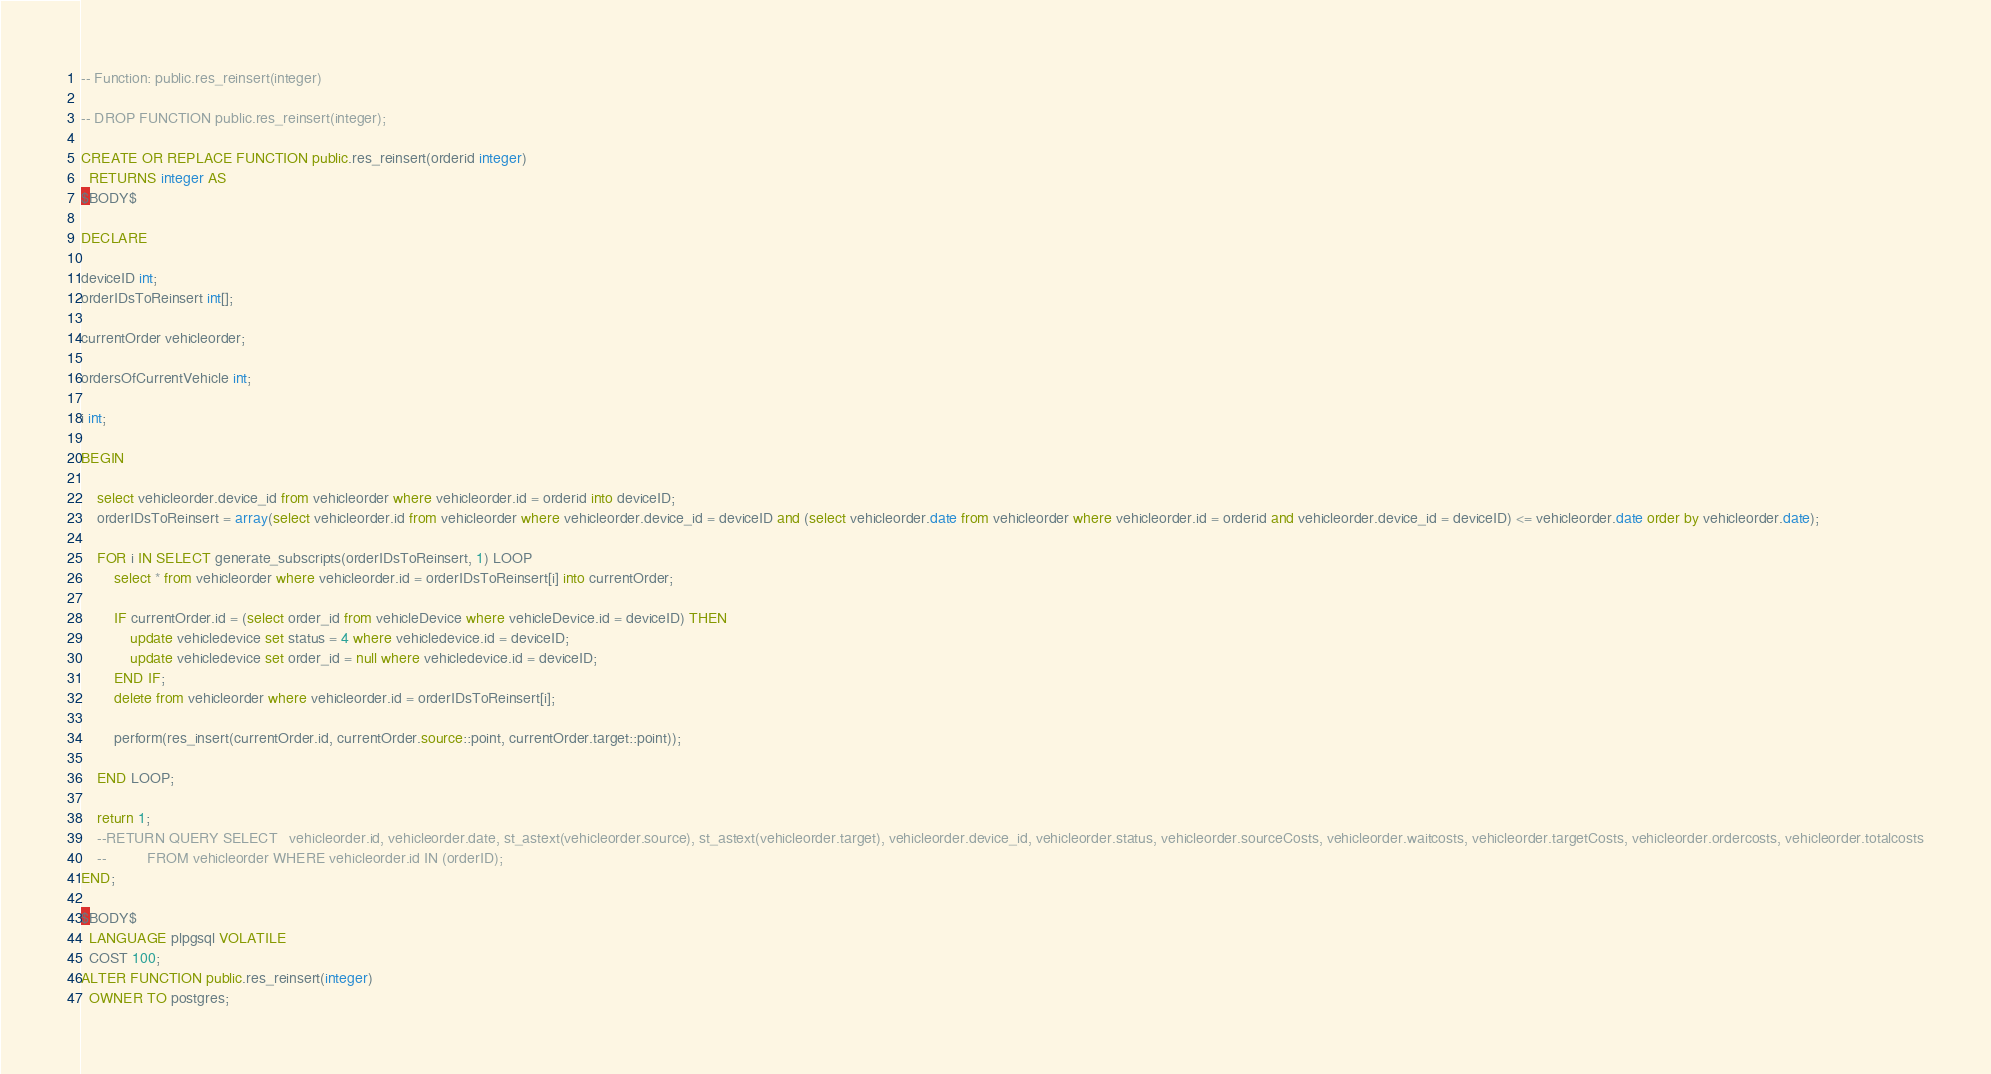Convert code to text. <code><loc_0><loc_0><loc_500><loc_500><_SQL_>-- Function: public.res_reinsert(integer)

-- DROP FUNCTION public.res_reinsert(integer);

CREATE OR REPLACE FUNCTION public.res_reinsert(orderid integer)
  RETURNS integer AS
$BODY$

DECLARE

deviceID int;
orderIDsToReinsert int[];

currentOrder vehicleorder;

ordersOfCurrentVehicle int;

i int;

BEGIN

	select vehicleorder.device_id from vehicleorder where vehicleorder.id = orderid into deviceID;
	orderIDsToReinsert = array(select vehicleorder.id from vehicleorder where vehicleorder.device_id = deviceID and (select vehicleorder.date from vehicleorder where vehicleorder.id = orderid and vehicleorder.device_id = deviceID) <= vehicleorder.date order by vehicleorder.date);

	FOR i IN SELECT generate_subscripts(orderIDsToReinsert, 1) LOOP
		select * from vehicleorder where vehicleorder.id = orderIDsToReinsert[i] into currentOrder;

		IF currentOrder.id = (select order_id from vehicleDevice where vehicleDevice.id = deviceID) THEN
			update vehicledevice set status = 4 where vehicledevice.id = deviceID;
			update vehicledevice set order_id = null where vehicledevice.id = deviceID;
		END IF;
		delete from vehicleorder where vehicleorder.id = orderIDsToReinsert[i];

		perform(res_insert(currentOrder.id, currentOrder.source::point, currentOrder.target::point));  
		
	END LOOP;

	return 1;
	--RETURN QUERY SELECT 	vehicleorder.id, vehicleorder.date, st_astext(vehicleorder.source), st_astext(vehicleorder.target), vehicleorder.device_id, vehicleorder.status, vehicleorder.sourceCosts, vehicleorder.waitcosts, vehicleorder.targetCosts, vehicleorder.ordercosts, vehicleorder.totalcosts
	--			FROM vehicleorder WHERE vehicleorder.id IN (orderID);
END;

$BODY$
  LANGUAGE plpgsql VOLATILE
  COST 100;
ALTER FUNCTION public.res_reinsert(integer)
  OWNER TO postgres;
</code> 